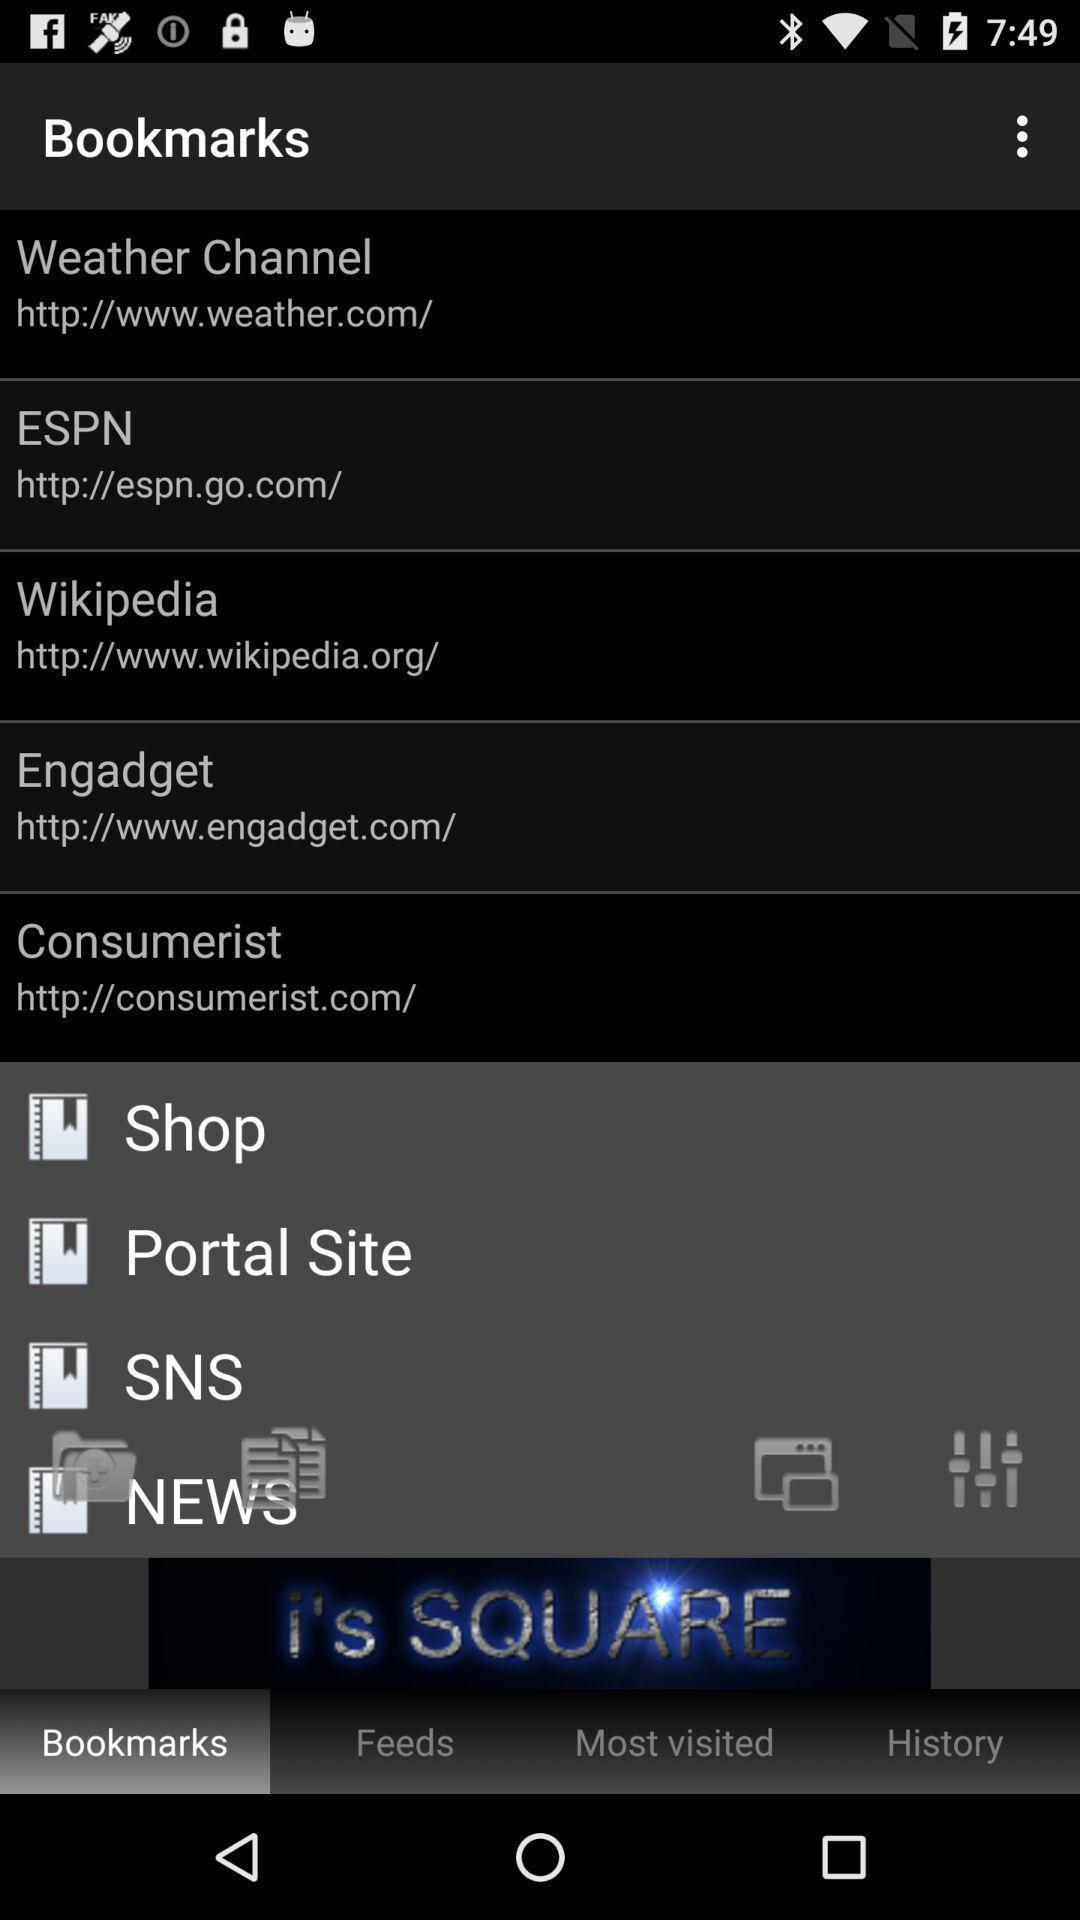What is the URL of "Wikipedia"? The URL is http://www.wikipedia.org/. 